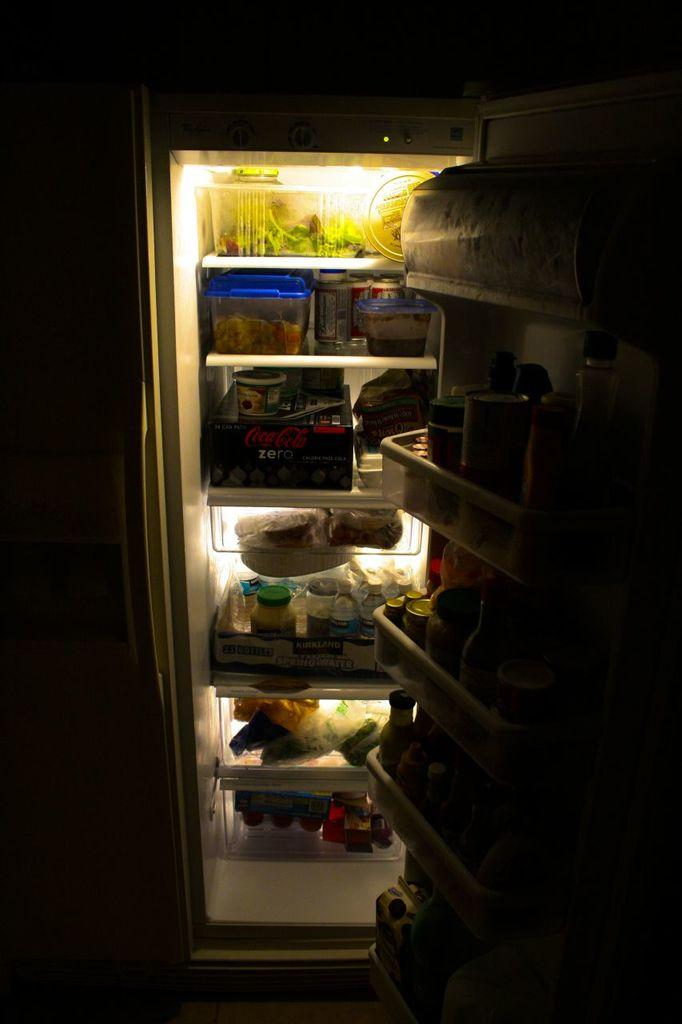<image>
Render a clear and concise summary of the photo. The inside of a fridge with products such as Coke Zero 